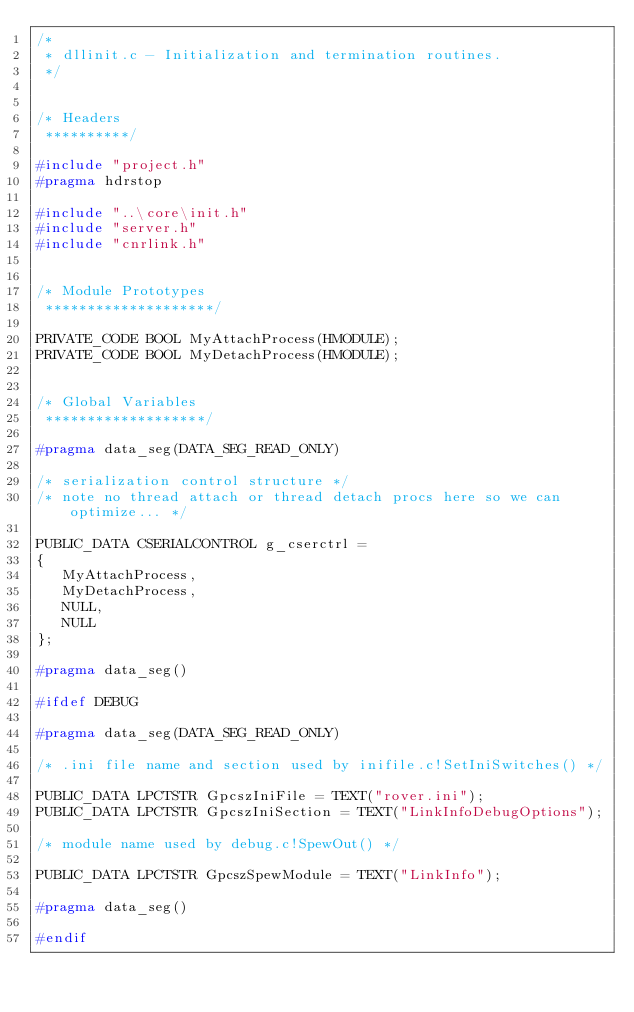Convert code to text. <code><loc_0><loc_0><loc_500><loc_500><_C_>/*
 * dllinit.c - Initialization and termination routines.
 */


/* Headers
 **********/

#include "project.h"
#pragma hdrstop

#include "..\core\init.h"
#include "server.h"
#include "cnrlink.h"


/* Module Prototypes
 ********************/

PRIVATE_CODE BOOL MyAttachProcess(HMODULE);
PRIVATE_CODE BOOL MyDetachProcess(HMODULE);


/* Global Variables
 *******************/

#pragma data_seg(DATA_SEG_READ_ONLY)

/* serialization control structure */
/* note no thread attach or thread detach procs here so we can optimize... */

PUBLIC_DATA CSERIALCONTROL g_cserctrl =
{
   MyAttachProcess,
   MyDetachProcess,
   NULL,
   NULL
};

#pragma data_seg()

#ifdef DEBUG

#pragma data_seg(DATA_SEG_READ_ONLY)

/* .ini file name and section used by inifile.c!SetIniSwitches() */

PUBLIC_DATA LPCTSTR GpcszIniFile = TEXT("rover.ini");
PUBLIC_DATA LPCTSTR GpcszIniSection = TEXT("LinkInfoDebugOptions");

/* module name used by debug.c!SpewOut() */

PUBLIC_DATA LPCTSTR GpcszSpewModule = TEXT("LinkInfo");

#pragma data_seg()

#endif
</code> 